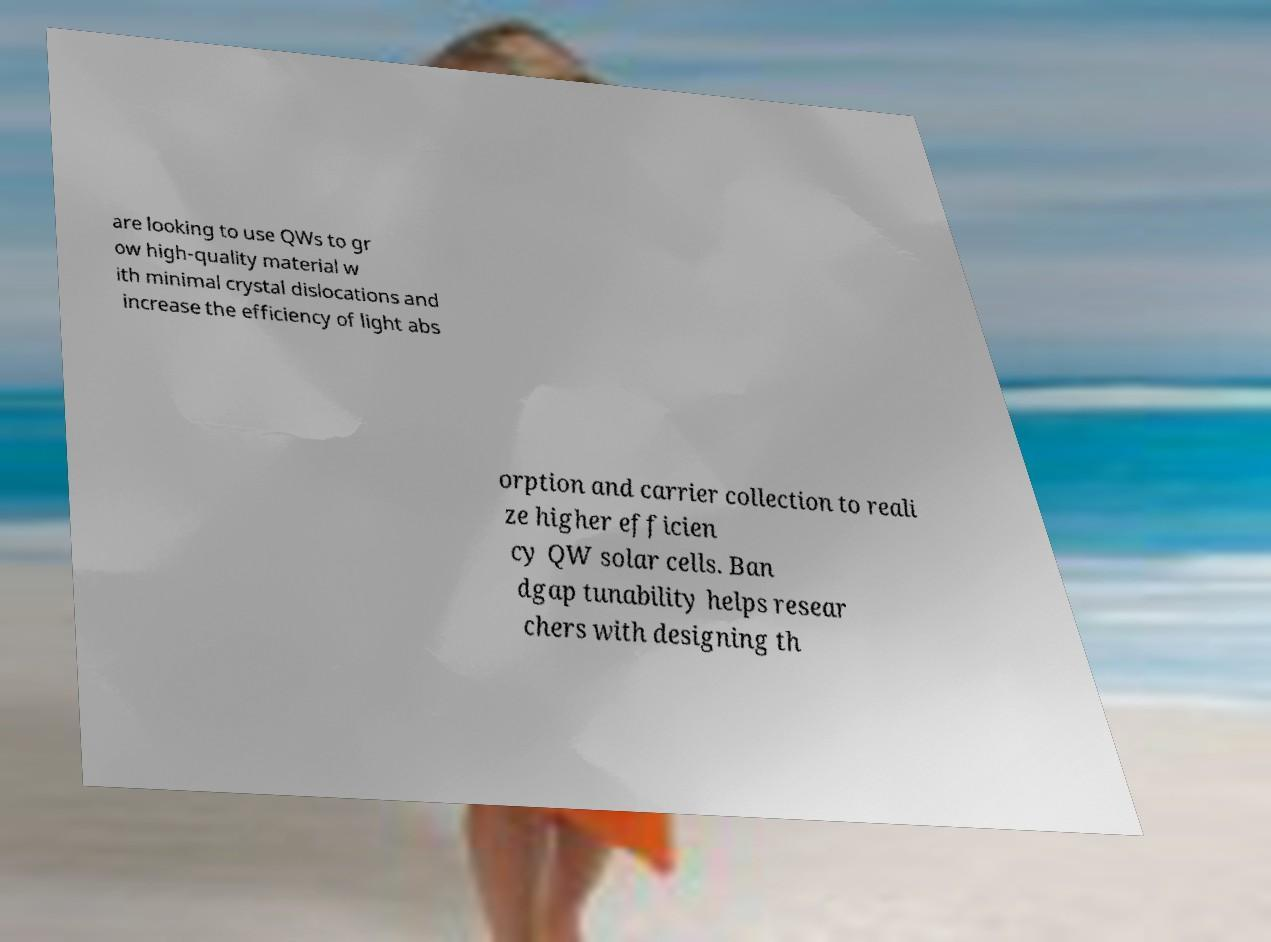Can you accurately transcribe the text from the provided image for me? are looking to use QWs to gr ow high-quality material w ith minimal crystal dislocations and increase the efficiency of light abs orption and carrier collection to reali ze higher efficien cy QW solar cells. Ban dgap tunability helps resear chers with designing th 